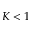Convert formula to latex. <formula><loc_0><loc_0><loc_500><loc_500>K < 1</formula> 